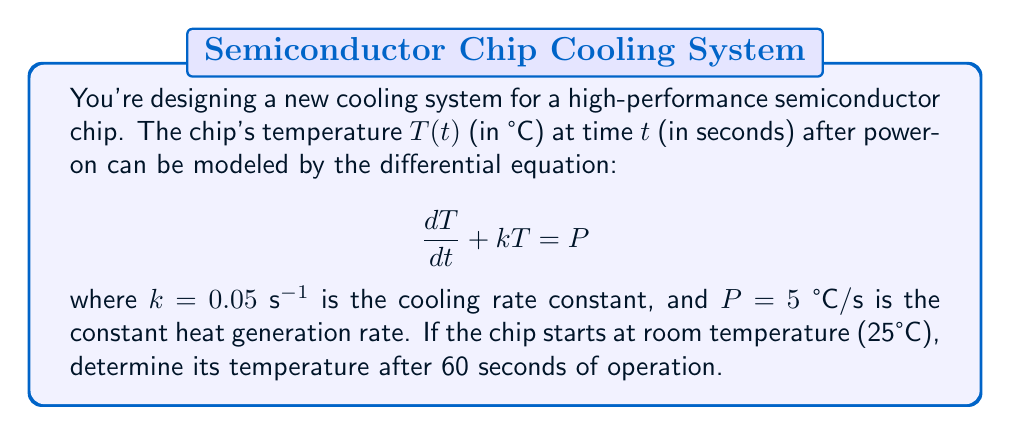Teach me how to tackle this problem. To solve this problem, we need to follow these steps:

1) First, we recognize this as a first-order linear differential equation.

2) The general solution for this type of equation is:

   $$T(t) = T_h + (T_0 - T_h)e^{-kt}$$

   where $T_h$ is the steady-state (homogeneous) solution, and $T_0$ is the initial temperature.

3) To find $T_h$, we set $\frac{dT}{dt} = 0$ in the original equation:

   $$0 + kT_h = P$$
   $$T_h = \frac{P}{k} = \frac{5}{0.05} = 100\text{ °C}$$

4) We're given $T_0 = 25\text{ °C}$, $k = 0.05\text{ s}^{-1}$, and we need to find $T(60)$.

5) Plugging these values into our solution:

   $$T(60) = 100 + (25 - 100)e^{-0.05 \cdot 60}$$

6) Simplifying:

   $$T(60) = 100 - 75e^{-3}$$

7) Calculating the exponential:

   $$T(60) \approx 100 - 75 \cdot 0.0498 \approx 96.27\text{ °C}$$

Therefore, after 60 seconds, the chip's temperature will be approximately 96.27°C.
Answer: $96.27\text{ °C}$ 